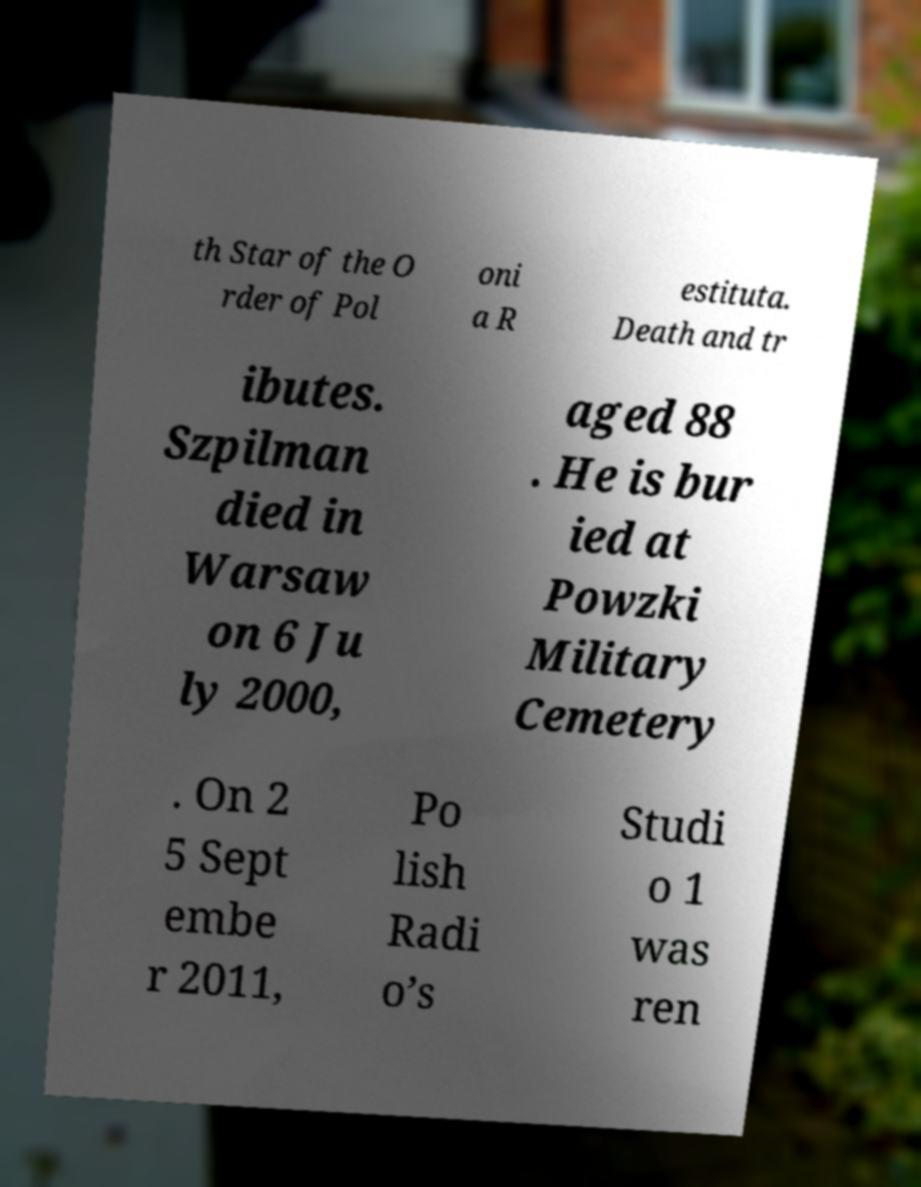What messages or text are displayed in this image? I need them in a readable, typed format. th Star of the O rder of Pol oni a R estituta. Death and tr ibutes. Szpilman died in Warsaw on 6 Ju ly 2000, aged 88 . He is bur ied at Powzki Military Cemetery . On 2 5 Sept embe r 2011, Po lish Radi o’s Studi o 1 was ren 